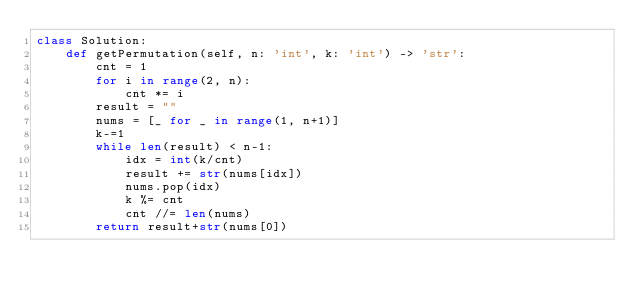<code> <loc_0><loc_0><loc_500><loc_500><_Python_>class Solution:
    def getPermutation(self, n: 'int', k: 'int') -> 'str':
        cnt = 1
        for i in range(2, n):
            cnt *= i
        result = ""
        nums = [_ for _ in range(1, n+1)]
        k-=1
        while len(result) < n-1:
            idx = int(k/cnt)
            result += str(nums[idx])
            nums.pop(idx)
            k %= cnt
            cnt //= len(nums)
        return result+str(nums[0])</code> 